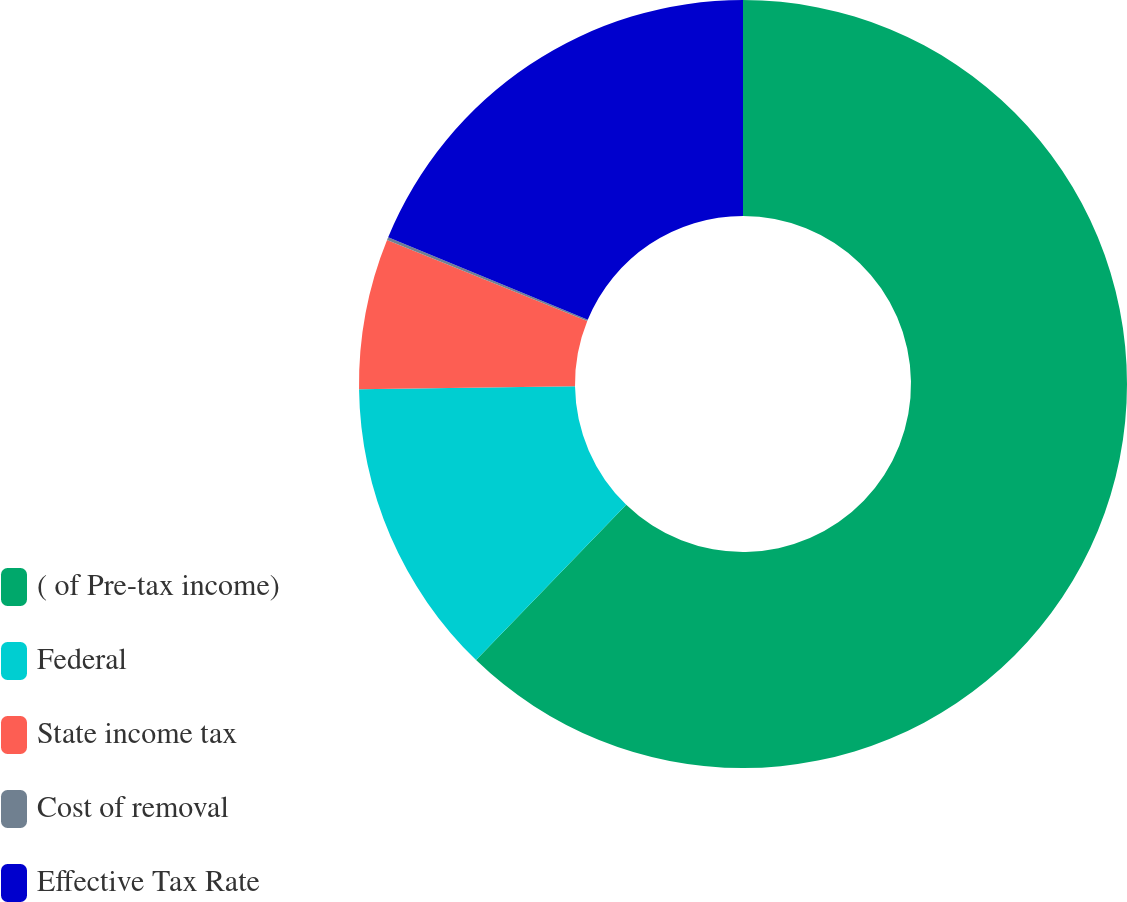Convert chart to OTSL. <chart><loc_0><loc_0><loc_500><loc_500><pie_chart><fcel>( of Pre-tax income)<fcel>Federal<fcel>State income tax<fcel>Cost of removal<fcel>Effective Tax Rate<nl><fcel>62.24%<fcel>12.55%<fcel>6.34%<fcel>0.12%<fcel>18.76%<nl></chart> 